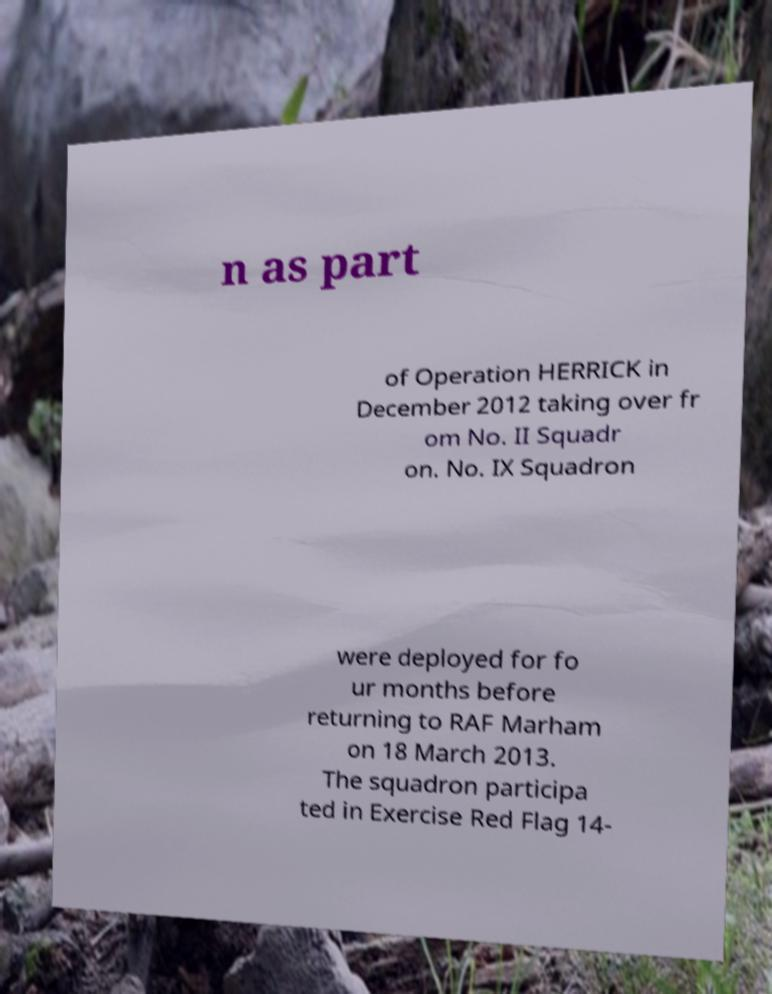Could you extract and type out the text from this image? n as part of Operation HERRICK in December 2012 taking over fr om No. II Squadr on. No. IX Squadron were deployed for fo ur months before returning to RAF Marham on 18 March 2013. The squadron participa ted in Exercise Red Flag 14- 